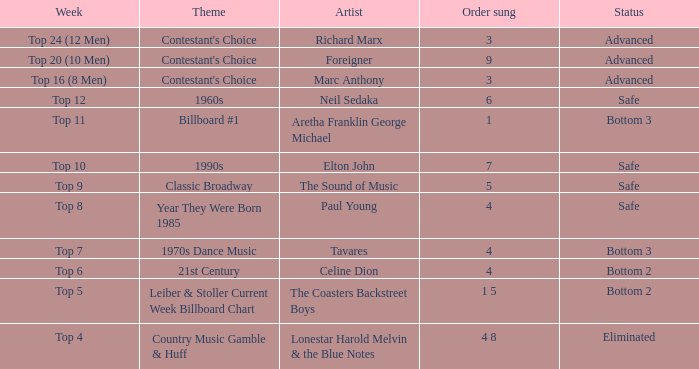I'm looking to parse the entire table for insights. Could you assist me with that? {'header': ['Week', 'Theme', 'Artist', 'Order sung', 'Status'], 'rows': [['Top 24 (12 Men)', "Contestant's Choice", 'Richard Marx', '3', 'Advanced'], ['Top 20 (10 Men)', "Contestant's Choice", 'Foreigner', '9', 'Advanced'], ['Top 16 (8 Men)', "Contestant's Choice", 'Marc Anthony', '3', 'Advanced'], ['Top 12', '1960s', 'Neil Sedaka', '6', 'Safe'], ['Top 11', 'Billboard #1', 'Aretha Franklin George Michael', '1', 'Bottom 3'], ['Top 10', '1990s', 'Elton John', '7', 'Safe'], ['Top 9', 'Classic Broadway', 'The Sound of Music', '5', 'Safe'], ['Top 8', 'Year They Were Born 1985', 'Paul Young', '4', 'Safe'], ['Top 7', '1970s Dance Music', 'Tavares', '4', 'Bottom 3'], ['Top 6', '21st Century', 'Celine Dion', '4', 'Bottom 2'], ['Top 5', 'Leiber & Stoller Current Week Billboard Chart', 'The Coasters Backstreet Boys', '1 5', 'Bottom 2'], ['Top 4', 'Country Music Gamble & Huff', 'Lonestar Harold Melvin & the Blue Notes', '4 8', 'Eliminated']]} At which point was a richard marx song performed in the order? 3.0. 